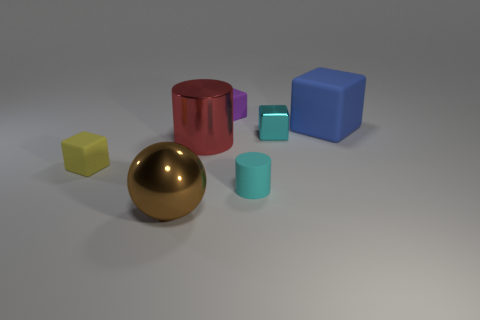Are there any cyan rubber balls that have the same size as the rubber cylinder? no 